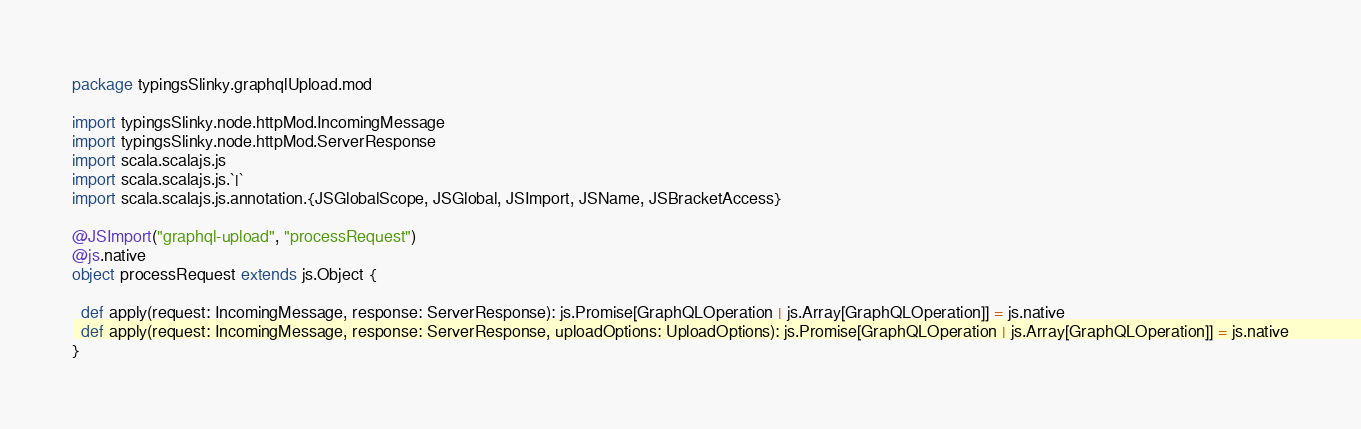<code> <loc_0><loc_0><loc_500><loc_500><_Scala_>package typingsSlinky.graphqlUpload.mod

import typingsSlinky.node.httpMod.IncomingMessage
import typingsSlinky.node.httpMod.ServerResponse
import scala.scalajs.js
import scala.scalajs.js.`|`
import scala.scalajs.js.annotation.{JSGlobalScope, JSGlobal, JSImport, JSName, JSBracketAccess}

@JSImport("graphql-upload", "processRequest")
@js.native
object processRequest extends js.Object {
  
  def apply(request: IncomingMessage, response: ServerResponse): js.Promise[GraphQLOperation | js.Array[GraphQLOperation]] = js.native
  def apply(request: IncomingMessage, response: ServerResponse, uploadOptions: UploadOptions): js.Promise[GraphQLOperation | js.Array[GraphQLOperation]] = js.native
}
</code> 